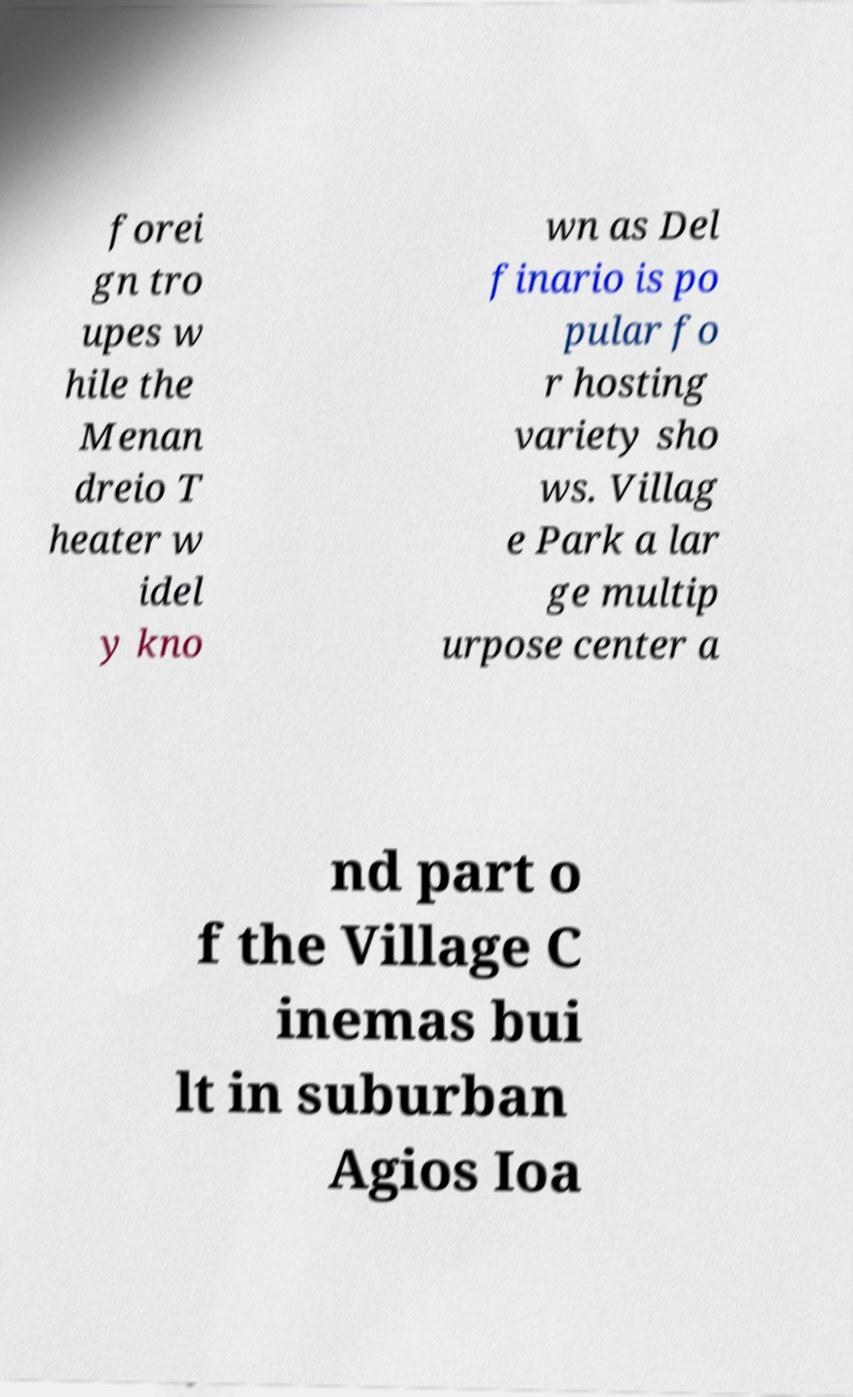Please identify and transcribe the text found in this image. forei gn tro upes w hile the Menan dreio T heater w idel y kno wn as Del finario is po pular fo r hosting variety sho ws. Villag e Park a lar ge multip urpose center a nd part o f the Village C inemas bui lt in suburban Agios Ioa 